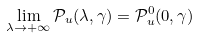Convert formula to latex. <formula><loc_0><loc_0><loc_500><loc_500>\lim _ { \lambda \to + \infty } \mathcal { P } _ { u } ( \lambda , \gamma ) = \mathcal { P } _ { u } ^ { 0 } ( 0 , \gamma )</formula> 